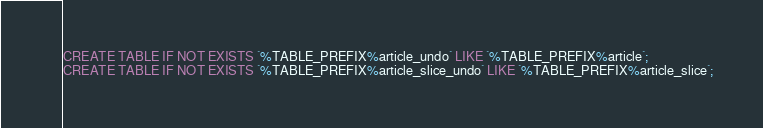Convert code to text. <code><loc_0><loc_0><loc_500><loc_500><_SQL_>CREATE TABLE IF NOT EXISTS `%TABLE_PREFIX%article_undo` LIKE `%TABLE_PREFIX%article`;
CREATE TABLE IF NOT EXISTS `%TABLE_PREFIX%article_slice_undo` LIKE `%TABLE_PREFIX%article_slice`;
</code> 